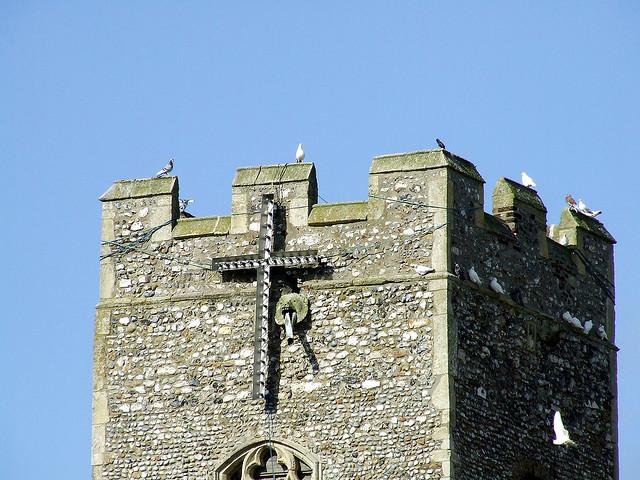Is there a clock on the building?
Quick response, please. No. Where is the cross?
Short answer required. Building. What is the symbol on the wall?
Be succinct. Cross. Is this a shopping mall?
Keep it brief. No. 